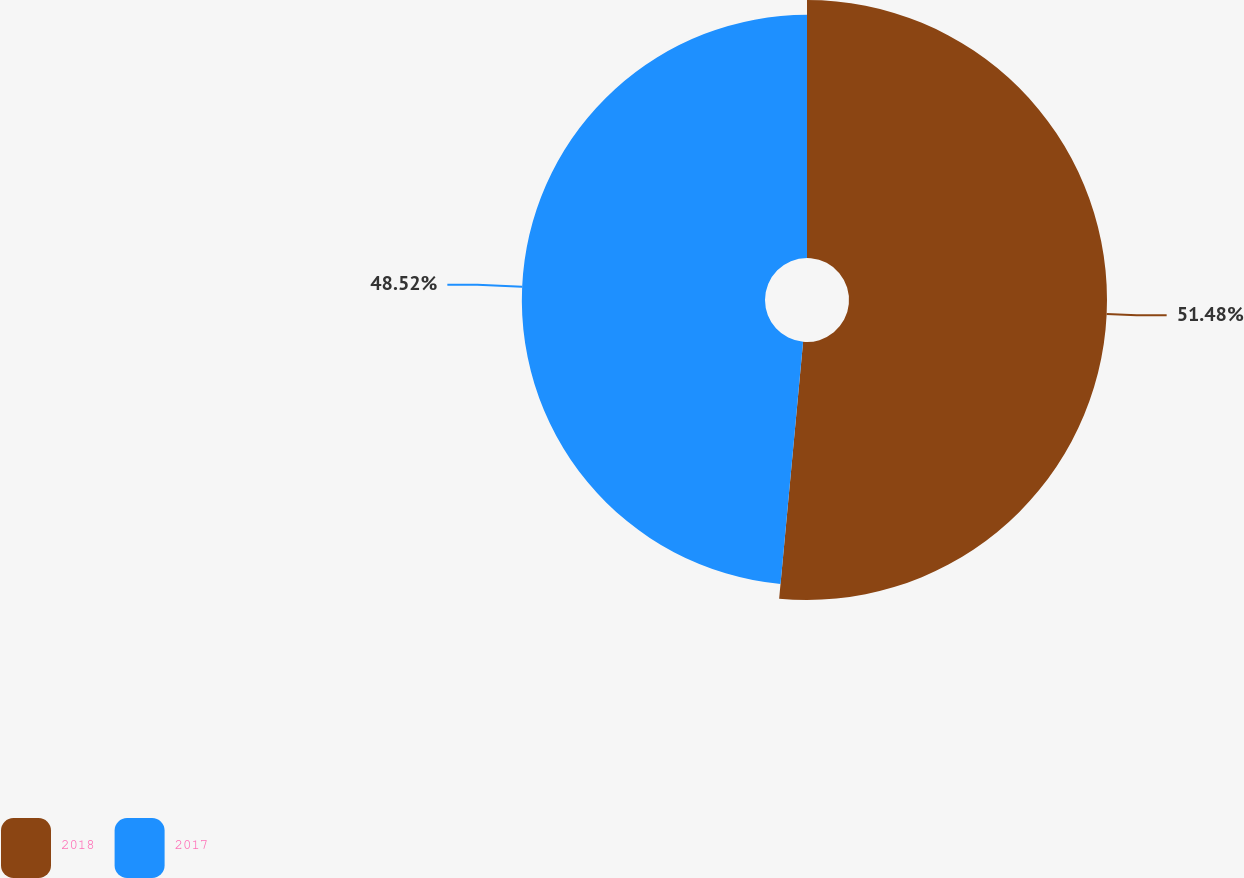Convert chart. <chart><loc_0><loc_0><loc_500><loc_500><pie_chart><fcel>2018<fcel>2017<nl><fcel>51.48%<fcel>48.52%<nl></chart> 